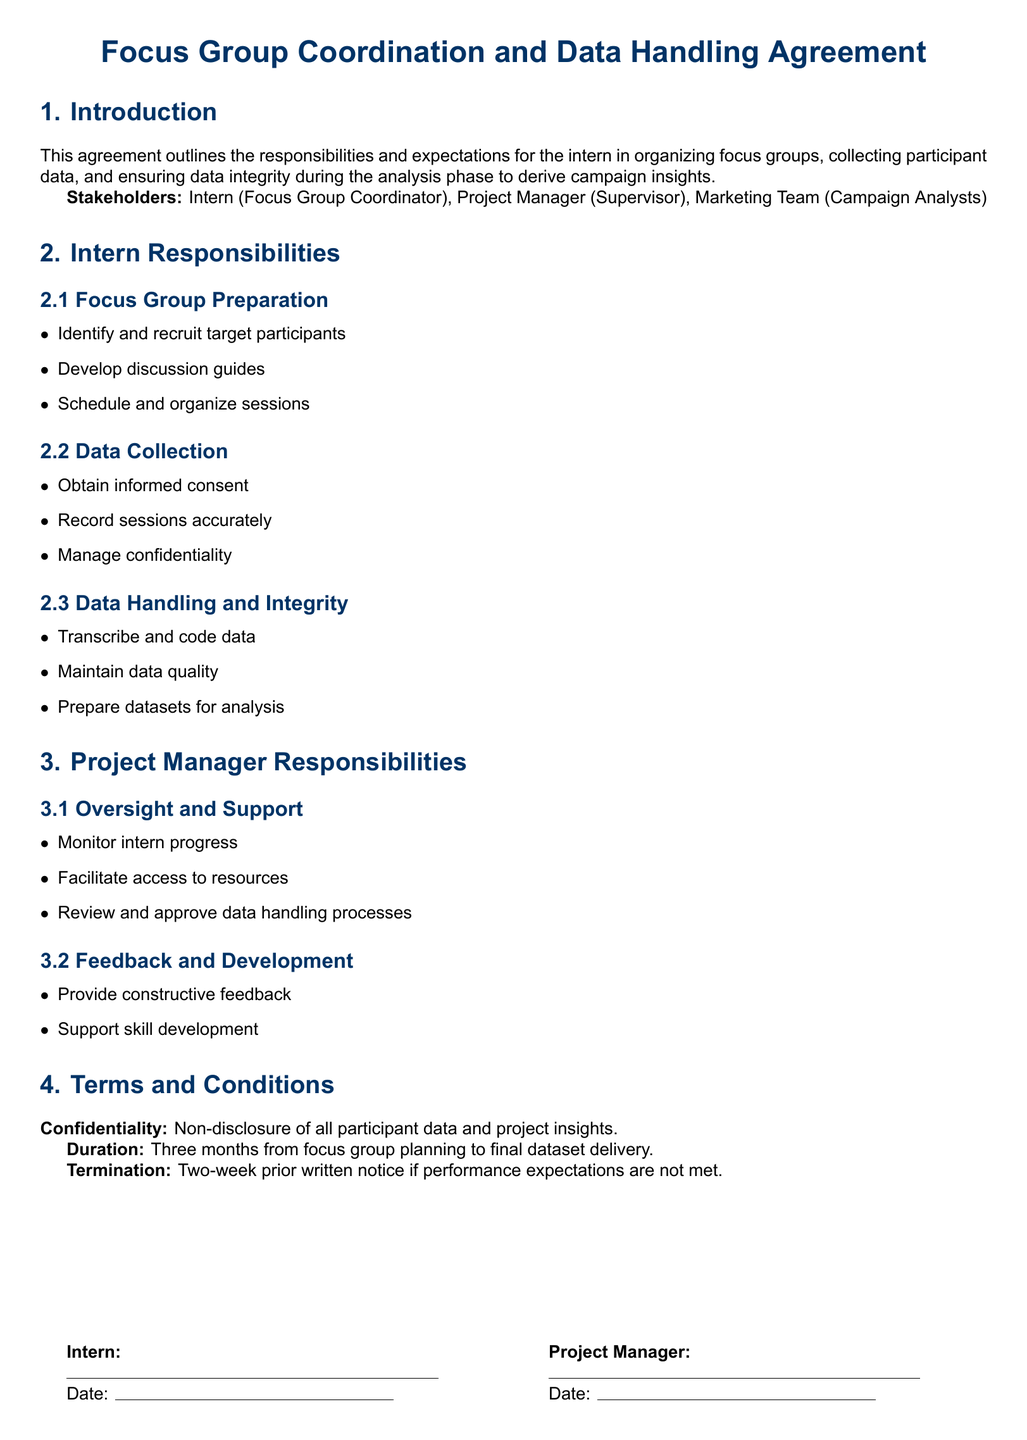What is the title of the document? The title is presented at the top of the document, indicating its main subject concerning focus group coordination.
Answer: Focus Group Coordination and Data Handling Agreement Who are the stakeholders mentioned in the document? The stakeholders are listed in the introduction section of the document.
Answer: Intern, Project Manager, Marketing Team What is the duration of the agreement? The document explicitly states the duration of the project related to focus group activities in the terms and conditions.
Answer: Three months What is required from the intern regarding data collection? The document outlines specific responsibilities assigned to the intern, including obtaining consent as part of data collection.
Answer: Obtain informed consent What must the Project Manager do to support the intern? The responsibilities of the Project Manager include oversight and support to the intern in their tasks.
Answer: Monitor intern progress What is the confidentiality requirement stated in the document? The terms and conditions section describes the confidentiality obligation concerning participant data.
Answer: Non-disclosure of all participant data and project insights What is the consequence of not meeting performance expectations? The document specifies a process for termination if performance expectations are not met.
Answer: Two-week prior written notice What should the intern prepare before analysis? One of the intern's responsibilities includes preparing the data for subsequent analysis phases.
Answer: Prepare datasets for analysis 